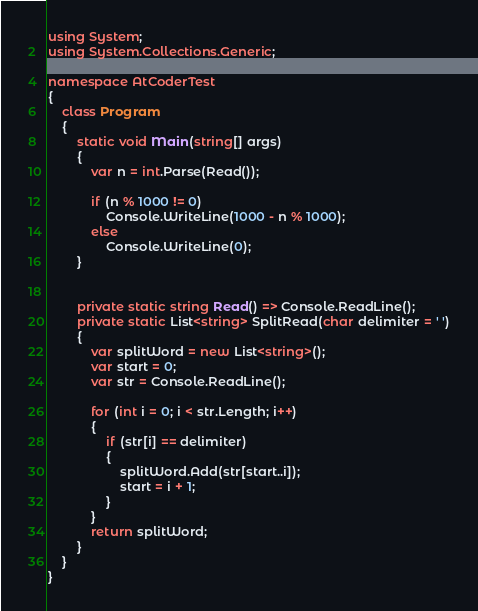Convert code to text. <code><loc_0><loc_0><loc_500><loc_500><_C#_>using System;
using System.Collections.Generic;

namespace AtCoderTest
{
    class Program
    {
        static void Main(string[] args)
        {
            var n = int.Parse(Read());

            if (n % 1000 != 0)
                Console.WriteLine(1000 - n % 1000);
            else
                Console.WriteLine(0);
        }


        private static string Read() => Console.ReadLine();
        private static List<string> SplitRead(char delimiter = ' ')
        {
            var splitWord = new List<string>();
            var start = 0;
            var str = Console.ReadLine();

            for (int i = 0; i < str.Length; i++)
            {
                if (str[i] == delimiter)
                {
                    splitWord.Add(str[start..i]);
                    start = i + 1;
                }
            }
            return splitWord;
        }
    }
}
</code> 